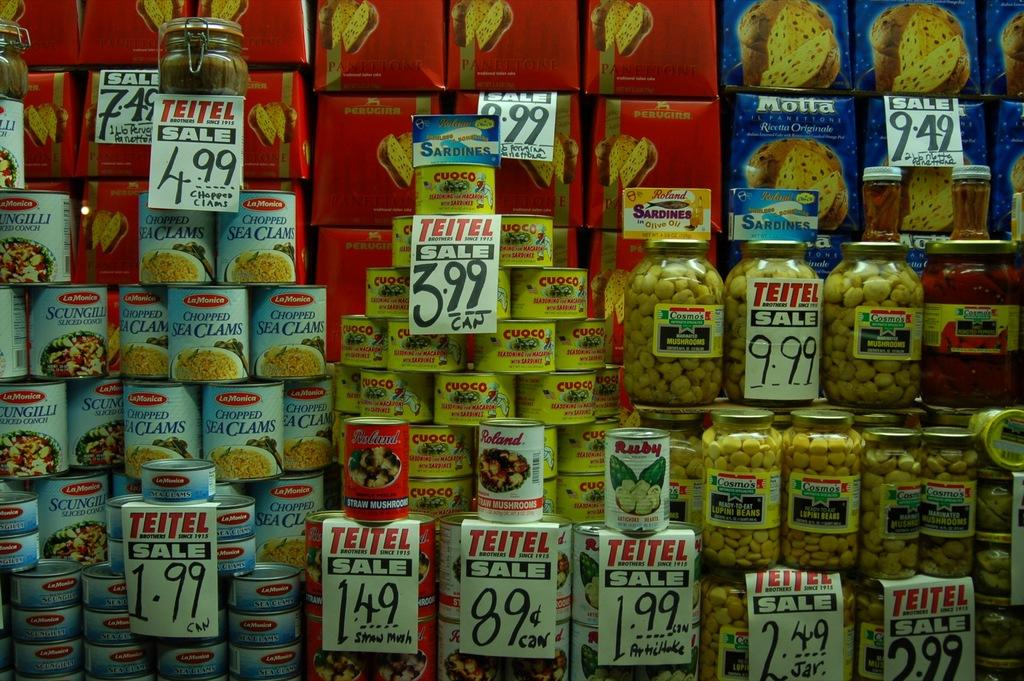<image>
Provide a brief description of the given image. cans of clam, bread, and other items are stacked on top of each other on a shelf 